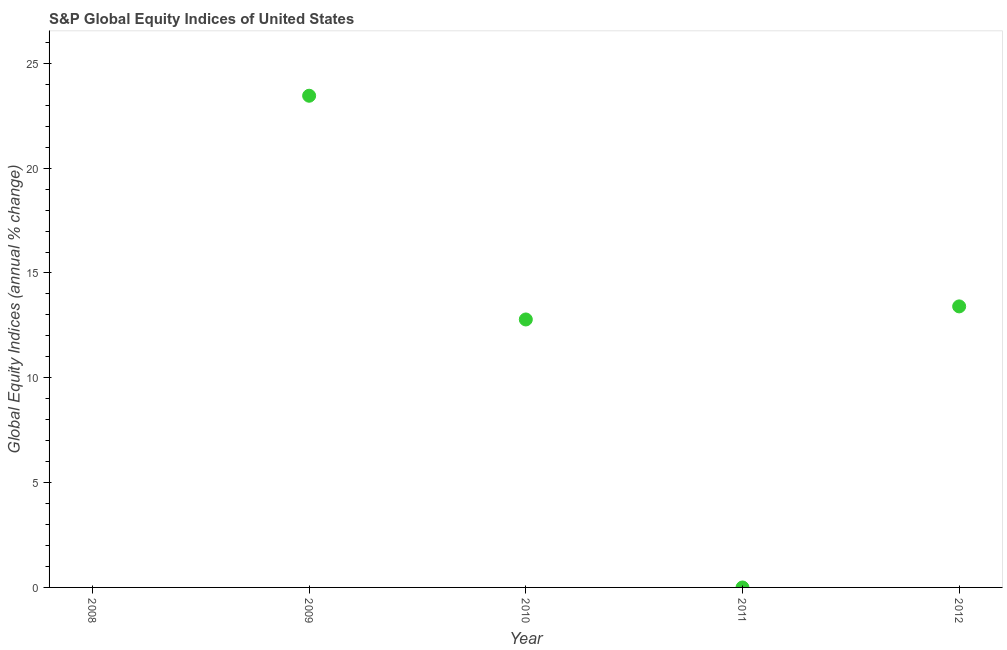What is the s&p global equity indices in 2012?
Make the answer very short. 13.41. Across all years, what is the maximum s&p global equity indices?
Provide a succinct answer. 23.45. Across all years, what is the minimum s&p global equity indices?
Make the answer very short. 0. What is the sum of the s&p global equity indices?
Offer a terse response. 49.64. What is the difference between the s&p global equity indices in 2009 and 2010?
Keep it short and to the point. 10.67. What is the average s&p global equity indices per year?
Your response must be concise. 9.93. What is the median s&p global equity indices?
Your answer should be compact. 12.78. What is the ratio of the s&p global equity indices in 2010 to that in 2012?
Provide a succinct answer. 0.95. Is the difference between the s&p global equity indices in 2009 and 2012 greater than the difference between any two years?
Provide a succinct answer. No. What is the difference between the highest and the second highest s&p global equity indices?
Offer a very short reply. 10.05. Is the sum of the s&p global equity indices in 2009 and 2012 greater than the maximum s&p global equity indices across all years?
Keep it short and to the point. Yes. What is the difference between the highest and the lowest s&p global equity indices?
Provide a short and direct response. 23.45. In how many years, is the s&p global equity indices greater than the average s&p global equity indices taken over all years?
Offer a very short reply. 3. How many years are there in the graph?
Provide a succinct answer. 5. Are the values on the major ticks of Y-axis written in scientific E-notation?
Keep it short and to the point. No. Does the graph contain any zero values?
Keep it short and to the point. Yes. Does the graph contain grids?
Keep it short and to the point. No. What is the title of the graph?
Offer a very short reply. S&P Global Equity Indices of United States. What is the label or title of the X-axis?
Provide a short and direct response. Year. What is the label or title of the Y-axis?
Offer a very short reply. Global Equity Indices (annual % change). What is the Global Equity Indices (annual % change) in 2009?
Provide a succinct answer. 23.45. What is the Global Equity Indices (annual % change) in 2010?
Provide a short and direct response. 12.78. What is the Global Equity Indices (annual % change) in 2012?
Make the answer very short. 13.41. What is the difference between the Global Equity Indices (annual % change) in 2009 and 2010?
Offer a very short reply. 10.67. What is the difference between the Global Equity Indices (annual % change) in 2009 and 2012?
Your answer should be very brief. 10.05. What is the difference between the Global Equity Indices (annual % change) in 2010 and 2012?
Your response must be concise. -0.62. What is the ratio of the Global Equity Indices (annual % change) in 2009 to that in 2010?
Keep it short and to the point. 1.83. What is the ratio of the Global Equity Indices (annual % change) in 2010 to that in 2012?
Keep it short and to the point. 0.95. 